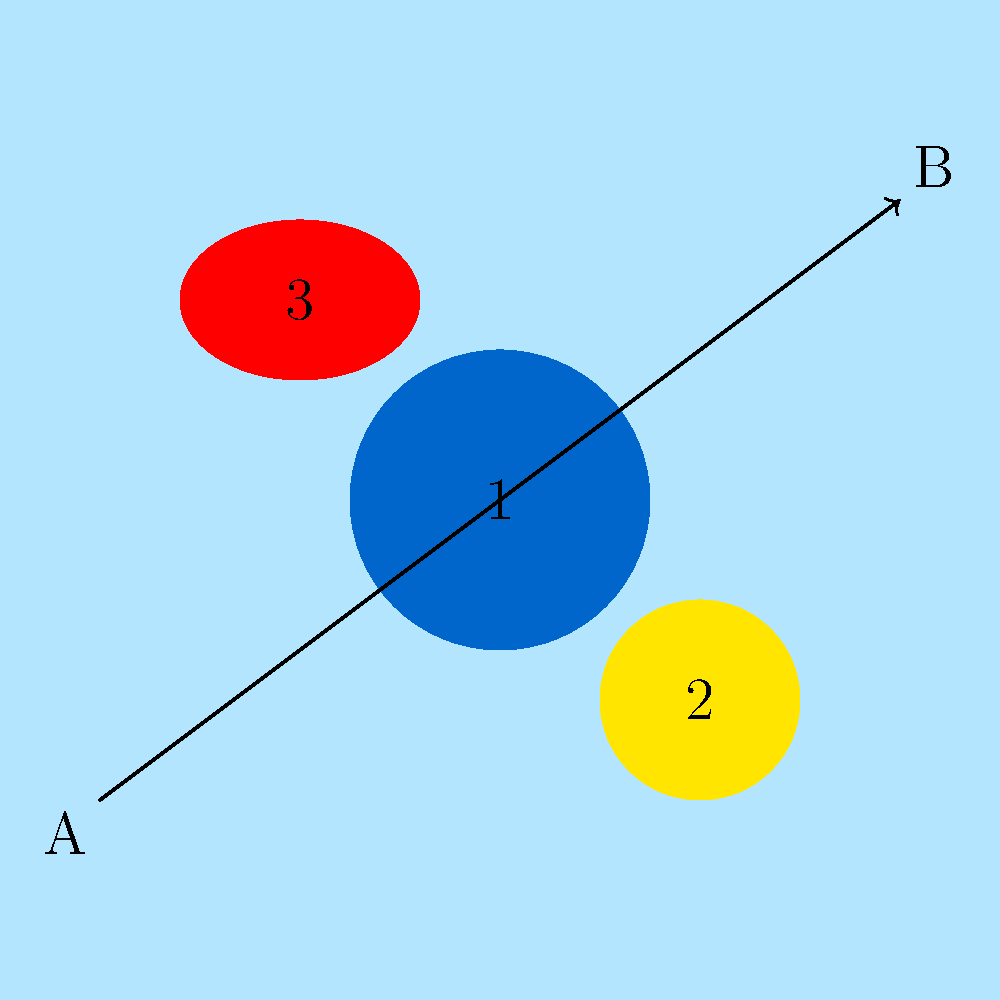An AI-enhanced weather radar display shows three storm systems along a proposed flight path from point A to point B. The storms are color-coded based on their intensity: blue (mild), yellow (moderate), and red (severe). Which storm system poses the greatest immediate threat to the flight, and what action should be taken? To answer this question, we need to analyze the AI-enhanced weather radar display and interpret the information provided:

1. Identify the storm systems:
   - Storm 1 (center): Blue, indicating mild intensity
   - Storm 2 (bottom right): Yellow, indicating moderate intensity
   - Storm 3 (top left): Red, indicating severe intensity

2. Assess the position of storms relative to the flight path:
   - Storm 1 is directly on the flight path
   - Storm 2 is close to the flight path but slightly off to the side
   - Storm 3 is off to the side and not directly on the flight path

3. Evaluate the threat level:
   - Storm 3 is the most severe (red) but not directly on the flight path
   - Storm 1 is mild (blue) but directly on the flight path
   - Storm 2 is moderate (yellow) and close to the flight path

4. Consider immediate threat and required action:
   - The greatest immediate threat is Storm 1, as it's directly on the flight path
   - Although it's mild, flying through any storm system can be dangerous
   - The safest action is to avoid all storm systems, especially those directly on the flight path

5. Determine the appropriate action:
   - The flight path should be adjusted to avoid all storm systems
   - Priority should be given to avoiding Storm 1, as it's directly on the current path
   - A new route should be planned that maintains a safe distance from all three storm systems

Therefore, Storm 1 poses the greatest immediate threat due to its position directly on the flight path, despite being less severe than the others. The appropriate action is to adjust the flight path to avoid all storm systems, with particular emphasis on avoiding Storm 1.
Answer: Storm 1; adjust flight path to avoid all storm systems, especially Storm 1. 